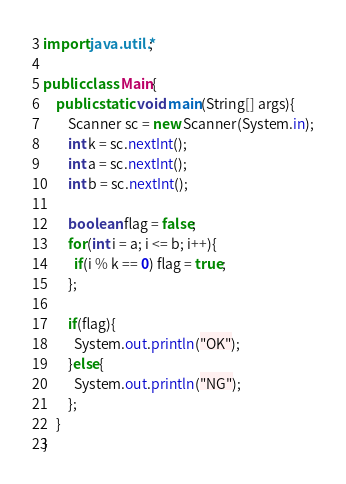Convert code to text. <code><loc_0><loc_0><loc_500><loc_500><_Java_>import java.util.*;

public class Main{
	public static void main(String[] args){
		Scanner sc = new Scanner(System.in);
        int k = sc.nextInt();
        int a = sc.nextInt();
        int b = sc.nextInt();
      
      	boolean flag = false;
      	for(int i = a; i <= b; i++){
          if(i % k == 0) flag = true;
        };

      	if(flag){
          System.out.println("OK");
        }else{
          System.out.println("NG");
        };
	}
}</code> 